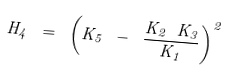Convert formula to latex. <formula><loc_0><loc_0><loc_500><loc_500>H _ { 4 } \ = \ \left ( K _ { 5 } \ - \ \frac { K _ { 2 } \ K _ { 3 } } { K _ { 1 } } \right ) ^ { 2 }</formula> 